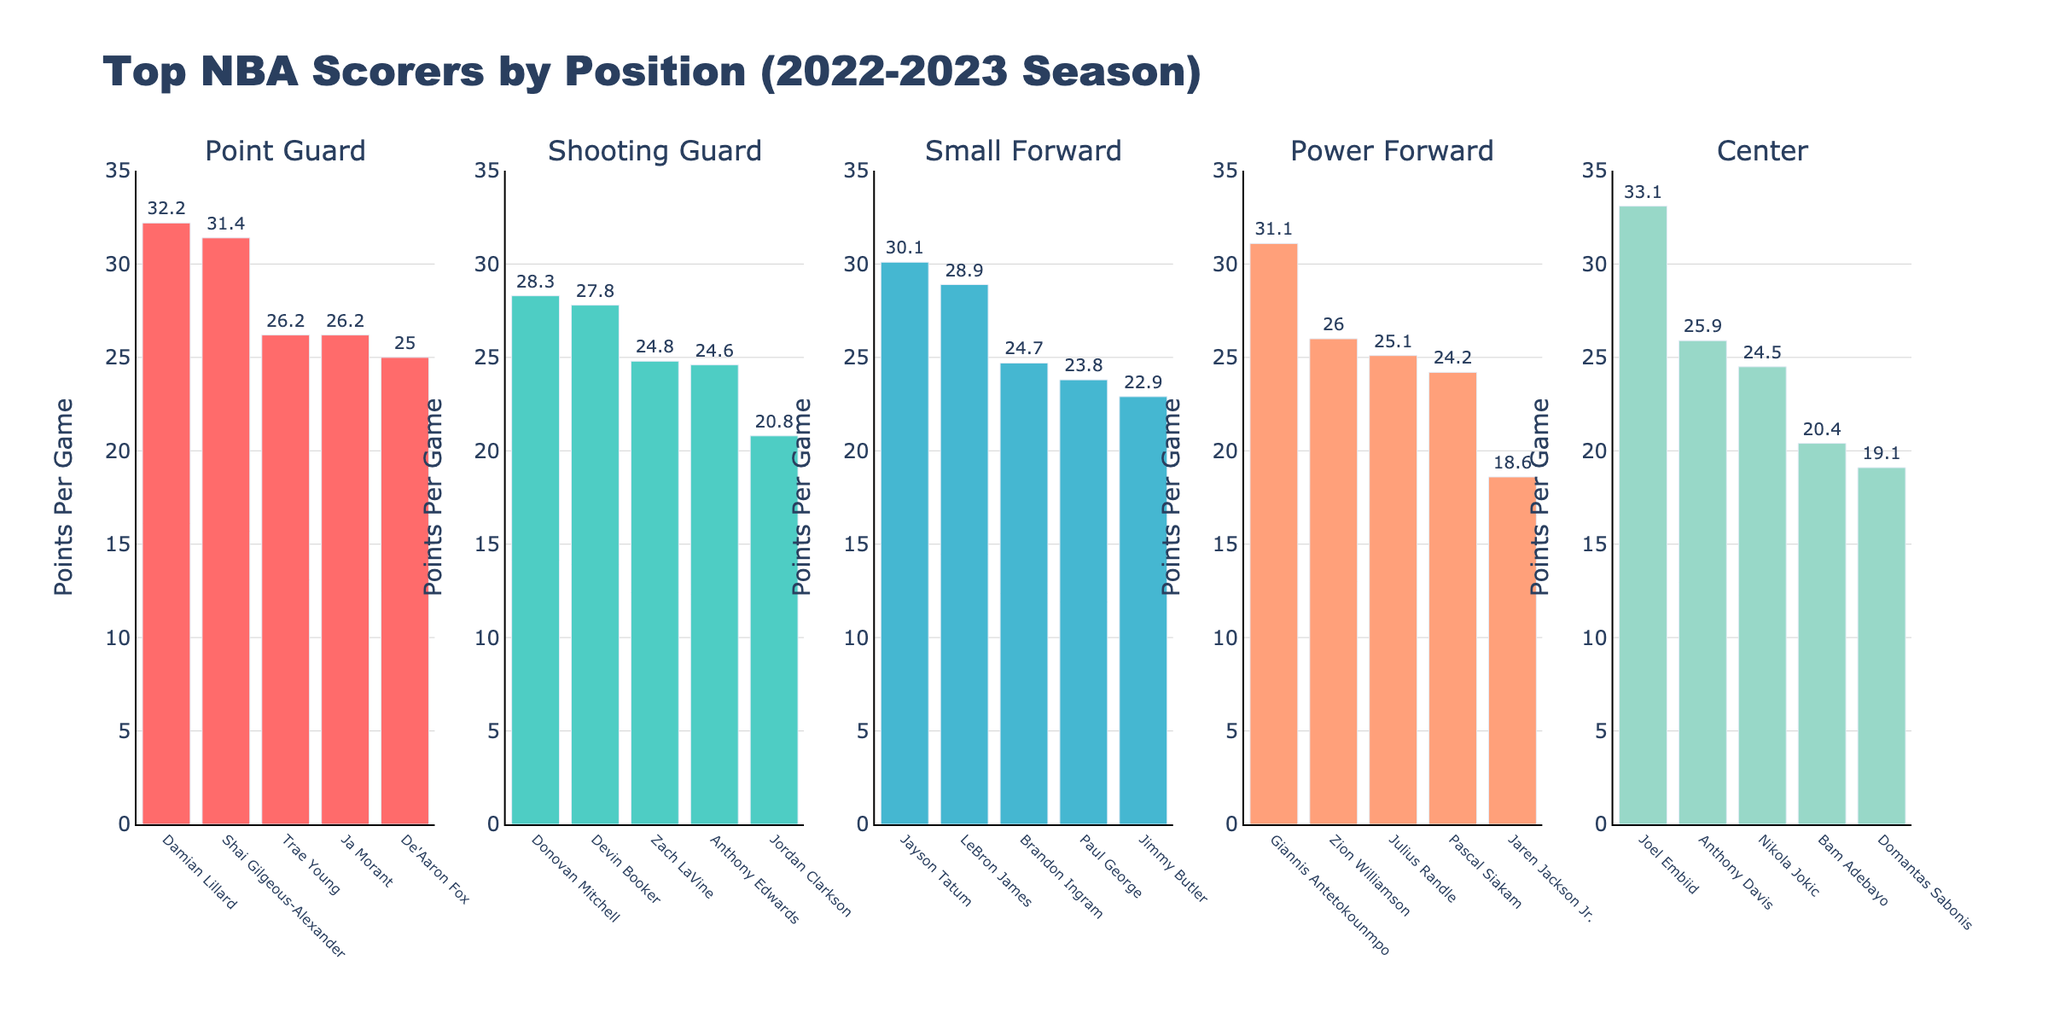What's the highest Points Per Game (PPG) among the Point Guards? From the bar chart, the tallest bar in the Point Guard section represents Damian Lillard with 32.2 PPG.
Answer: 32.2 Who scored more, LeBron James or Anthony Davis, and by how much? LeBron James scored 28.9 PPG while Anthony Davis scored 25.9 PPG. The difference is 28.9 - 25.9 = 3.0 PPG.
Answer: LeBron James, by 3.0 PPG What is the average Points Per Game (PPG) of the top three Centers? The top three Centers are Joel Embiid (33.1), Nikola Jokic (24.5), and Anthony Davis (25.9). Their average is (33.1 + 24.5 + 25.9) / 3 ≈ 27.83 PPG.
Answer: 27.83 Which position has the player with the highest individual Points Per Game (PPG), and who is that player? The highest individual PPG is 33.1 by Joel Embiid, who is a Center.
Answer: Center, Joel Embiid Compare the Points Per Game (PPG) of the highest-scoring players in Small Forward and Power Forward positions. Who scored more and by how much? The highest-scoring Small Forward is Jayson Tatum with 30.1 PPG, and the highest-scoring Power Forward is Giannis Antetokounmpo with 31.1 PPG. Giannis scored 31.1 - 30.1 = 1.0 PPG more than Tatum.
Answer: Giannis Antetokounmpo, by 1.0 PPG Which player has the second highest Points Per Game (PPG) among Shooting Guards, and what is their PPG? The second highest PPG among Shooting Guards is by Devin Booker, who scored 27.8 PPG.
Answer: Devin Booker, 27.8 How many players from the Center position scored above 20 PPG? Joel Embiid (33.1), Nikola Jokic (24.5), Anthony Davis (25.9), and Bam Adebayo (20.4) are Centers scoring above 20 PPG. There are 4 such players.
Answer: 4 What is the combined Points Per Game (PPG) of the lowest-scoring player in each position? The lowest-scoring players for each position are De'Aaron Fox (25.0), Jordan Clarkson (20.8), Jimmy Butler (22.9), Jaren Jackson Jr. (18.6), and Bam Adebayo (20.4). Their combined PPG is 25.0 + 20.8 + 22.9 + 18.6 + 20.4 = 107.7.
Answer: 107.7 In the category of Point Guards, who are tied and with what Points Per Game (PPG) value? Trae Young and Ja Morant are tied with 26.2 PPG.
Answer: Trae Young and Ja Morant, 26.2 